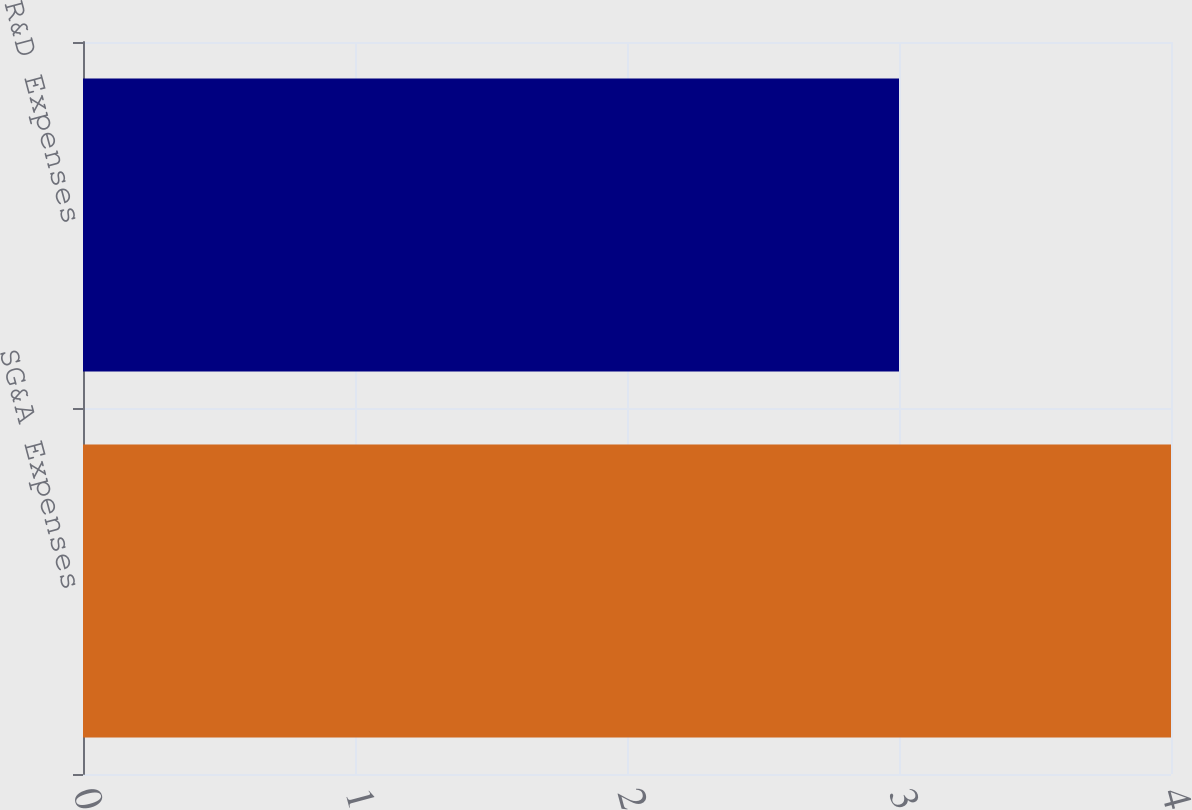Convert chart. <chart><loc_0><loc_0><loc_500><loc_500><bar_chart><fcel>SG&A Expenses<fcel>R&D Expenses<nl><fcel>4<fcel>3<nl></chart> 